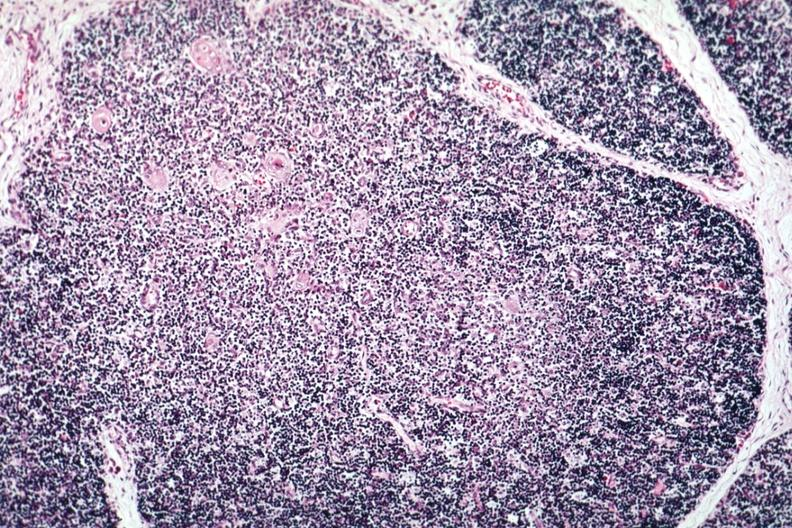s wonder present?
Answer the question using a single word or phrase. No 